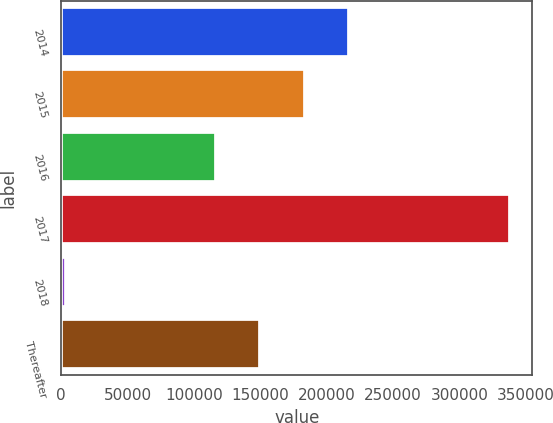Convert chart to OTSL. <chart><loc_0><loc_0><loc_500><loc_500><bar_chart><fcel>2014<fcel>2015<fcel>2016<fcel>2017<fcel>2018<fcel>Thereafter<nl><fcel>216778<fcel>183349<fcel>116492<fcel>338054<fcel>3769<fcel>149920<nl></chart> 